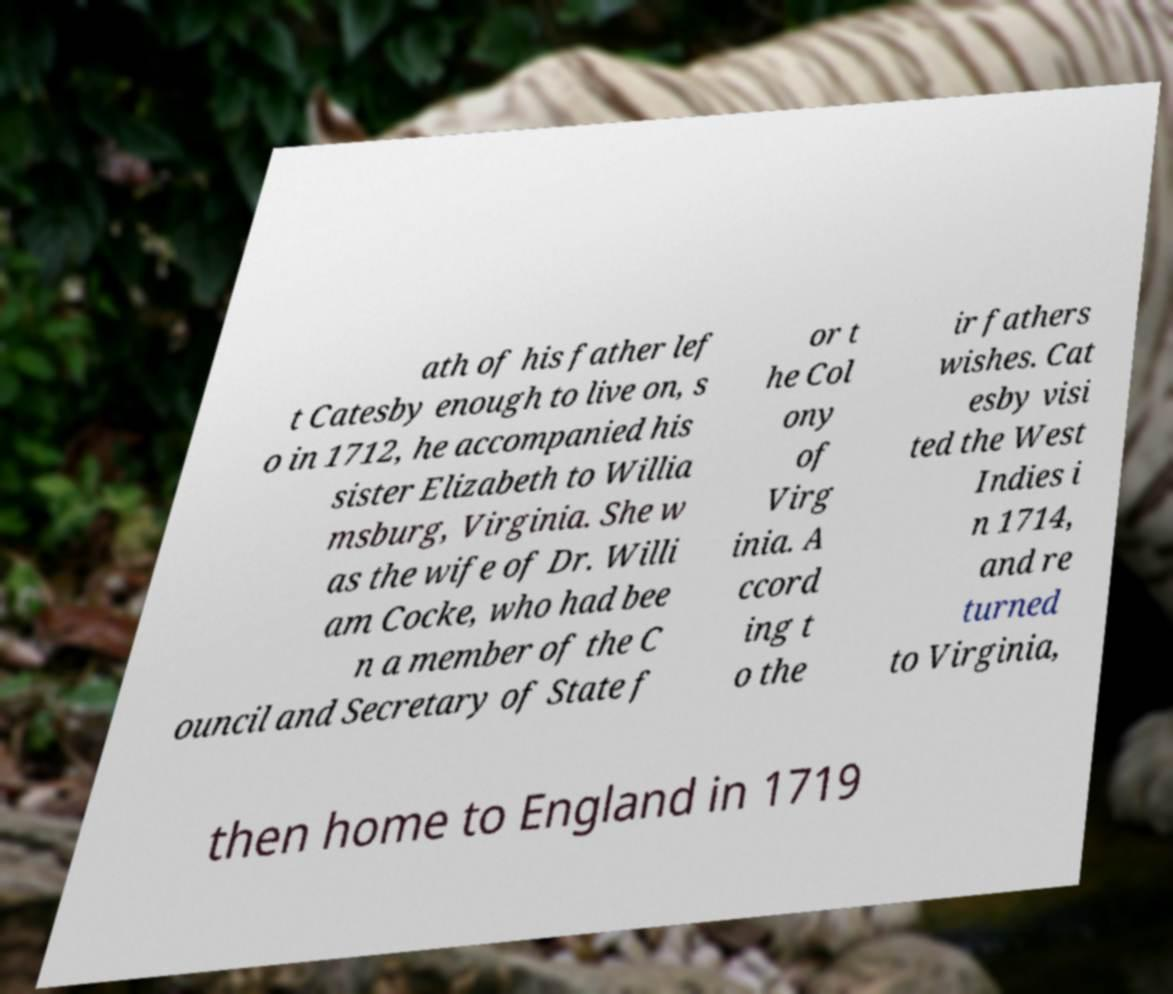Please identify and transcribe the text found in this image. ath of his father lef t Catesby enough to live on, s o in 1712, he accompanied his sister Elizabeth to Willia msburg, Virginia. She w as the wife of Dr. Willi am Cocke, who had bee n a member of the C ouncil and Secretary of State f or t he Col ony of Virg inia. A ccord ing t o the ir fathers wishes. Cat esby visi ted the West Indies i n 1714, and re turned to Virginia, then home to England in 1719 